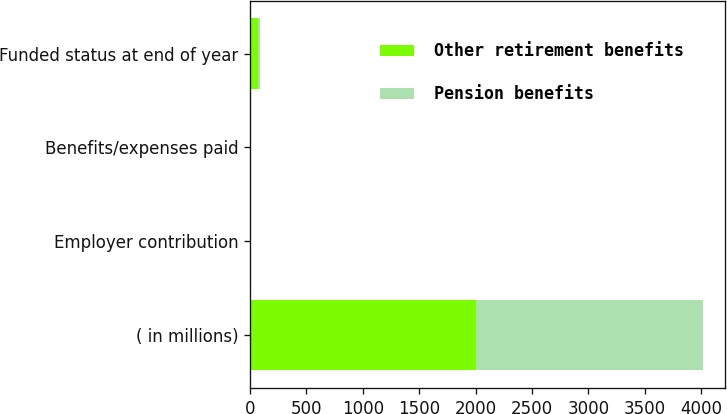Convert chart to OTSL. <chart><loc_0><loc_0><loc_500><loc_500><stacked_bar_chart><ecel><fcel>( in millions)<fcel>Employer contribution<fcel>Benefits/expenses paid<fcel>Funded status at end of year<nl><fcel>Other retirement benefits<fcel>2008<fcel>2.4<fcel>10.1<fcel>73<nl><fcel>Pension benefits<fcel>2008<fcel>0.3<fcel>0.7<fcel>15<nl></chart> 